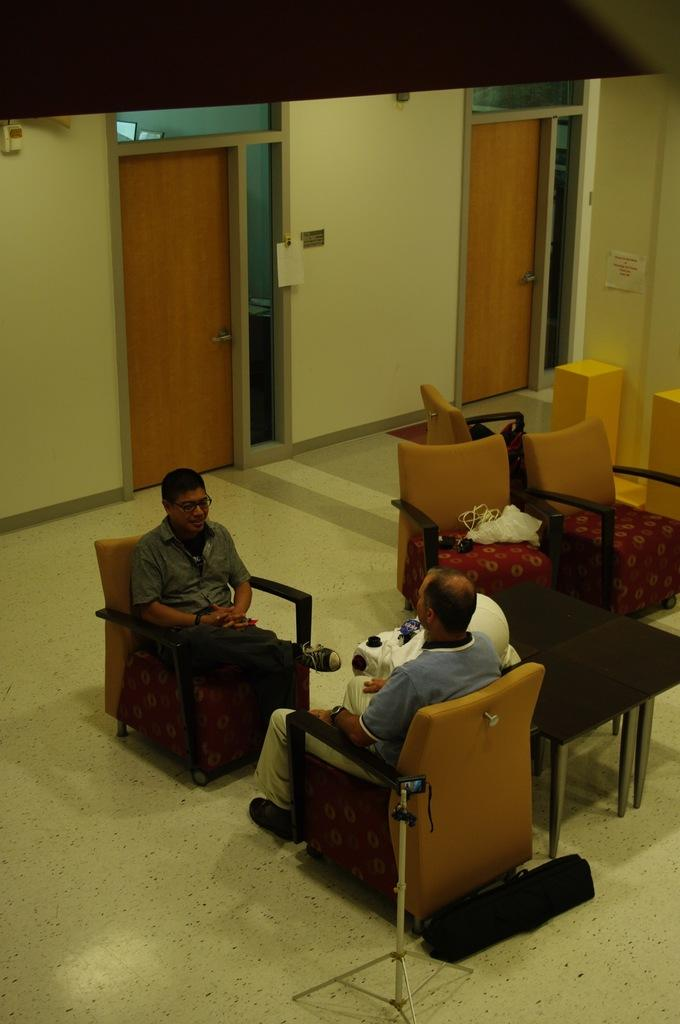How many people are sitting in the image? There are two persons sitting on chairs in the image. What can be seen in the image besides the people sitting? There is a video camera, a table, and a door in the image. What type of riddle can be seen written on the door in the image? There is no riddle written on the door in the image; it is just a door. 